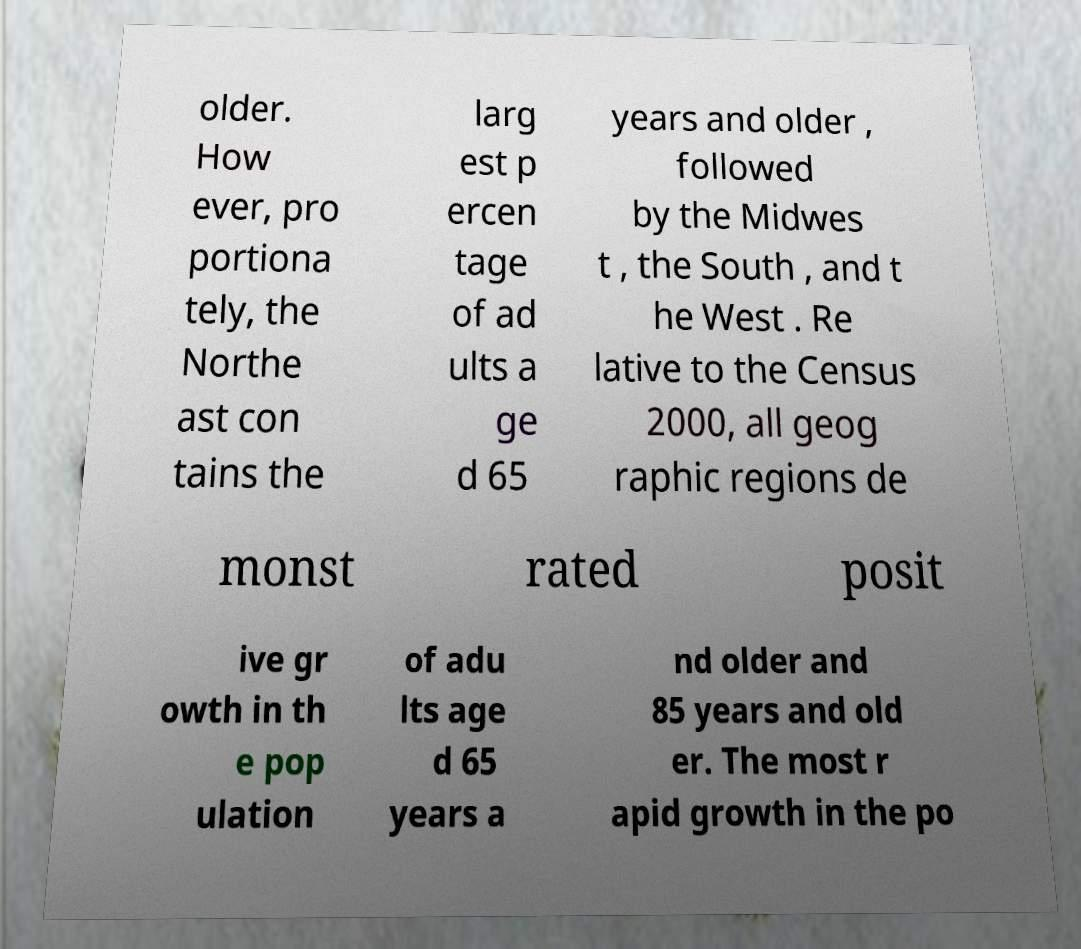Could you assist in decoding the text presented in this image and type it out clearly? older. How ever, pro portiona tely, the Northe ast con tains the larg est p ercen tage of ad ults a ge d 65 years and older , followed by the Midwes t , the South , and t he West . Re lative to the Census 2000, all geog raphic regions de monst rated posit ive gr owth in th e pop ulation of adu lts age d 65 years a nd older and 85 years and old er. The most r apid growth in the po 